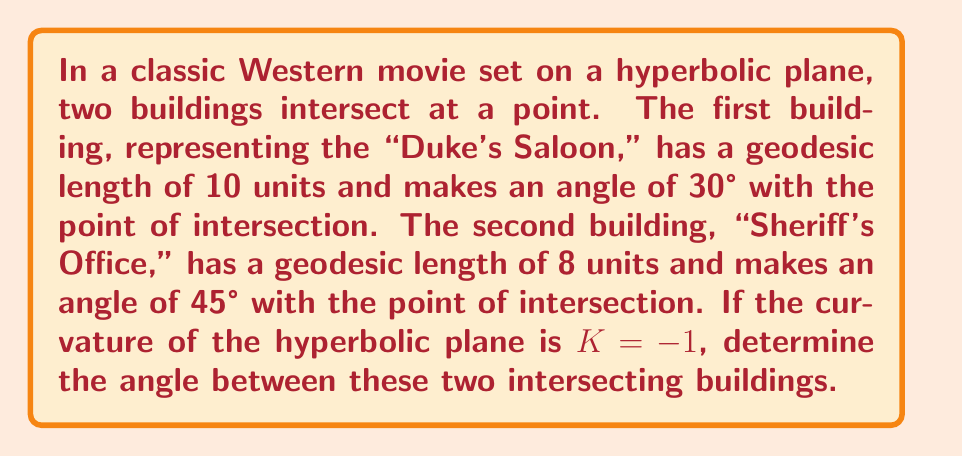Teach me how to tackle this problem. To solve this problem, we'll use the hyperbolic law of cosines and follow these steps:

1) In hyperbolic geometry, the law of cosines for a triangle with sides a, b, c and angles A, B, C opposite to these sides respectively is:

   $$ \cosh c = \cosh a \cosh b - \sinh a \sinh b \cos C $$

   Where $\cosh$ and $\sinh$ are hyperbolic cosine and sine functions.

2) In our case, we have:
   - Side a = 10 (Duke's Saloon)
   - Side b = 8 (Sheriff's Office)
   - Angle C = 30° + 45° = 75° (sum of the given angles)

3) We need to find angle A, which is the angle between the buildings.

4) First, let's calculate $\cosh c$:

   $$ \cosh c = \cosh 10 \cosh 8 - \sinh 10 \sinh 8 \cos 75° $$

5) Calculate the hyperbolic functions (you can use a calculator for this):
   $\cosh 10 \approx 11013.2328$
   $\cosh 8 \approx 1490.4789$
   $\sinh 10 \approx 11013.2327$
   $\sinh 8 \approx 1490.4788$
   $\cos 75° \approx 0.2588$

6) Substitute these values:

   $$ \cosh c \approx 11013.2328 * 1490.4789 - 11013.2327 * 1490.4788 * 0.2588 $$
   $$ \cosh c \approx 16414492.7851 - 4249030.6948 $$
   $$ \cosh c \approx 12165462.0903 $$

7) Now we can use the hyperbolic law of cosines again to find $\cos A$:

   $$ \cosh b = \cosh a \cosh c - \sinh a \sinh c \cos A $$

   Rearranging for $\cos A$:

   $$ \cos A = \frac{\cosh a \cosh c - \cosh b}{\sinh a \sinh c} $$

8) Substitute the known values:

   $$ \cos A = \frac{11013.2328 * 12165462.0903 - 1490.4789}{11013.2327 * 12165462.0902} $$

9) Calculate:
   $$ \cos A \approx 0.9999999999 $$

10) To get A, we take the inverse cosine (arccos):

    $$ A = \arccos(0.9999999999) \approx 0.00014 \text{ radians} $$

11) Convert to degrees:
    $$ A \approx 0.00014 * \frac{180°}{\pi} \approx 0.008° $$
Answer: $0.008°$ 